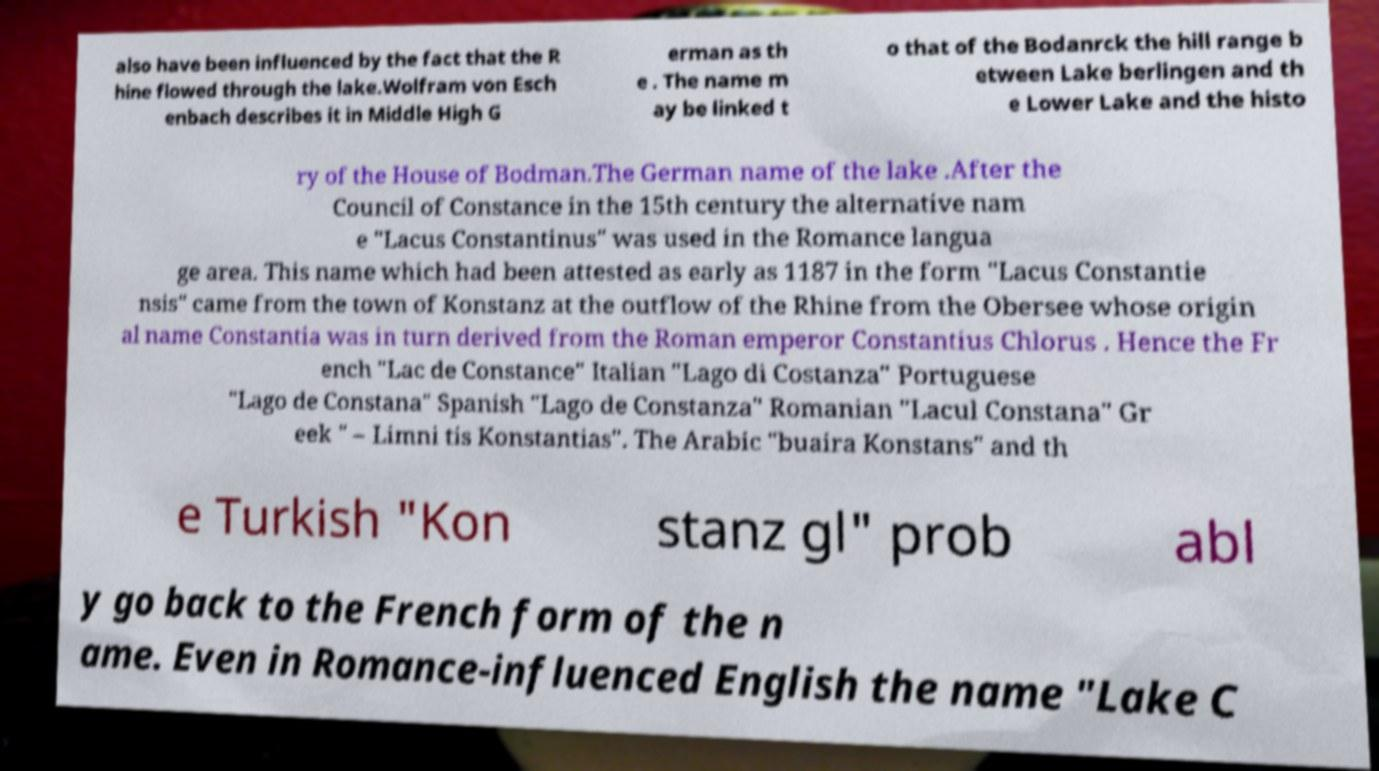What messages or text are displayed in this image? I need them in a readable, typed format. also have been influenced by the fact that the R hine flowed through the lake.Wolfram von Esch enbach describes it in Middle High G erman as th e . The name m ay be linked t o that of the Bodanrck the hill range b etween Lake berlingen and th e Lower Lake and the histo ry of the House of Bodman.The German name of the lake .After the Council of Constance in the 15th century the alternative nam e "Lacus Constantinus" was used in the Romance langua ge area. This name which had been attested as early as 1187 in the form "Lacus Constantie nsis" came from the town of Konstanz at the outflow of the Rhine from the Obersee whose origin al name Constantia was in turn derived from the Roman emperor Constantius Chlorus . Hence the Fr ench "Lac de Constance" Italian "Lago di Costanza" Portuguese "Lago de Constana" Spanish "Lago de Constanza" Romanian "Lacul Constana" Gr eek " – Limni tis Konstantias". The Arabic "buaira Konstans" and th e Turkish "Kon stanz gl" prob abl y go back to the French form of the n ame. Even in Romance-influenced English the name "Lake C 